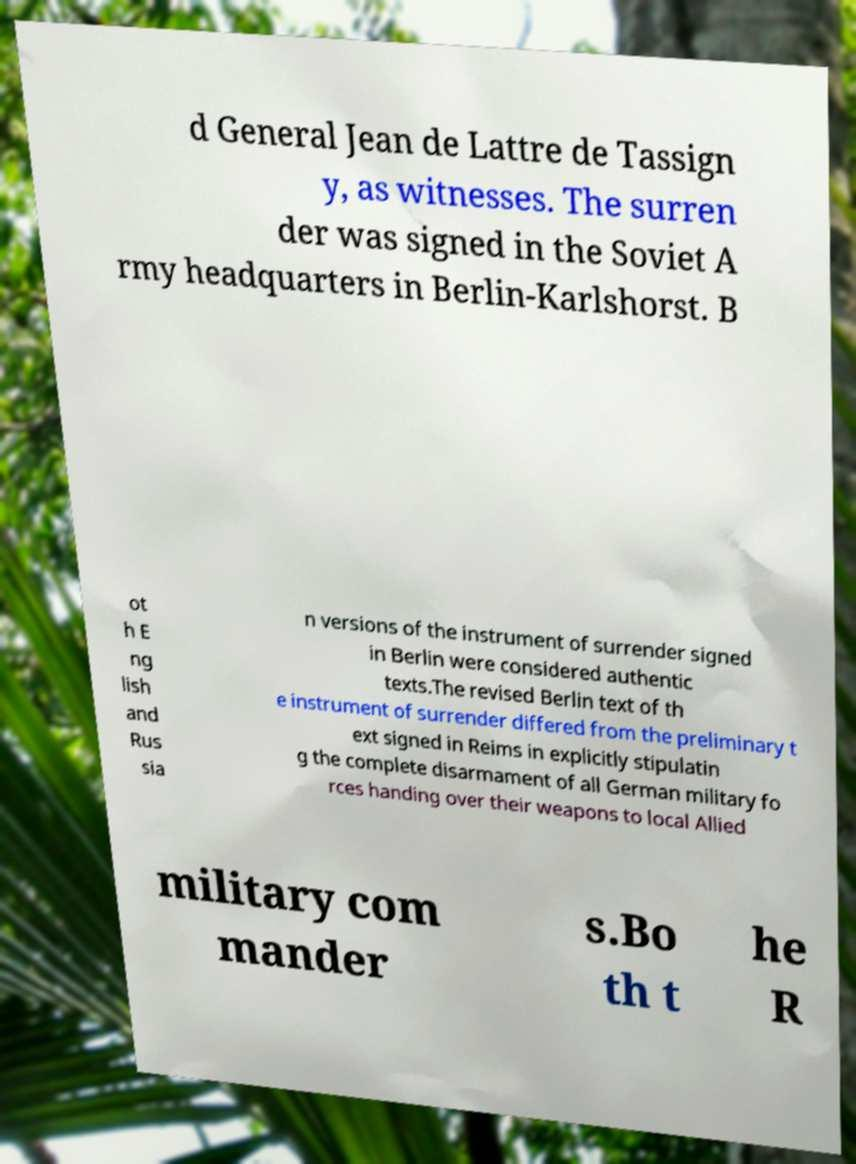What messages or text are displayed in this image? I need them in a readable, typed format. d General Jean de Lattre de Tassign y, as witnesses. The surren der was signed in the Soviet A rmy headquarters in Berlin-Karlshorst. B ot h E ng lish and Rus sia n versions of the instrument of surrender signed in Berlin were considered authentic texts.The revised Berlin text of th e instrument of surrender differed from the preliminary t ext signed in Reims in explicitly stipulatin g the complete disarmament of all German military fo rces handing over their weapons to local Allied military com mander s.Bo th t he R 